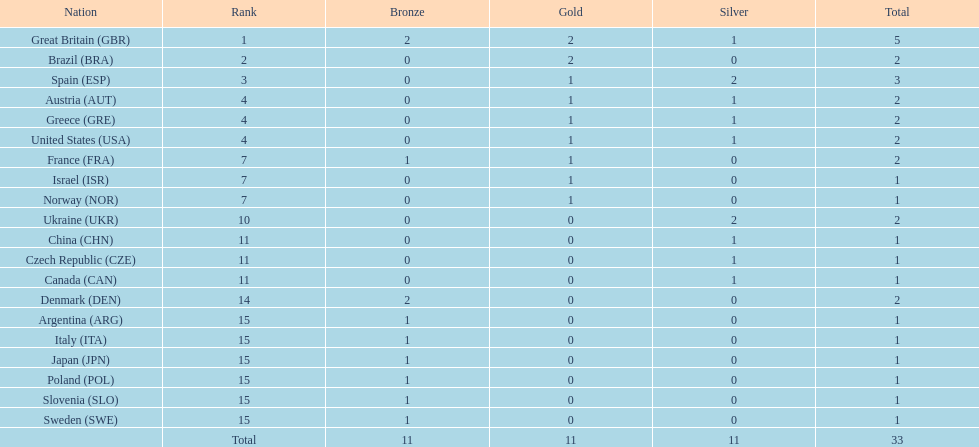What country had the most medals? Great Britain. 